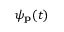Convert formula to latex. <formula><loc_0><loc_0><loc_500><loc_500>\psi _ { p } ( t )</formula> 